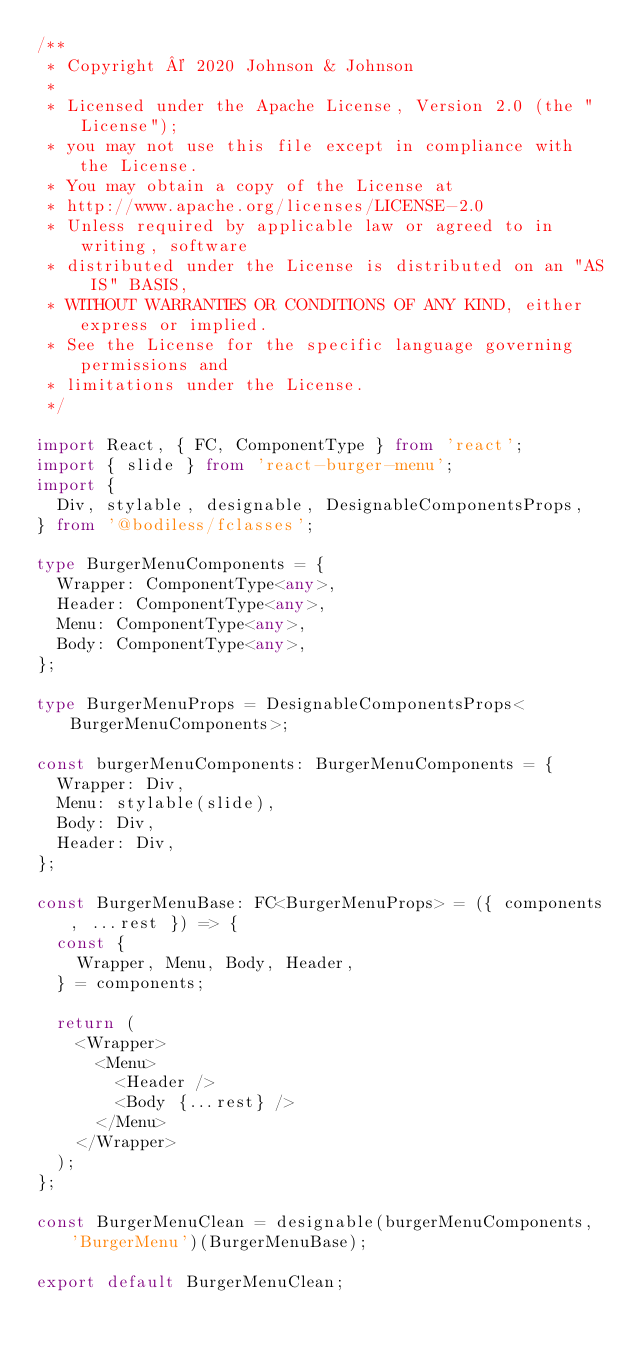Convert code to text. <code><loc_0><loc_0><loc_500><loc_500><_TypeScript_>/**
 * Copyright © 2020 Johnson & Johnson
 *
 * Licensed under the Apache License, Version 2.0 (the "License");
 * you may not use this file except in compliance with the License.
 * You may obtain a copy of the License at
 * http://www.apache.org/licenses/LICENSE-2.0
 * Unless required by applicable law or agreed to in writing, software
 * distributed under the License is distributed on an "AS IS" BASIS,
 * WITHOUT WARRANTIES OR CONDITIONS OF ANY KIND, either express or implied.
 * See the License for the specific language governing permissions and
 * limitations under the License.
 */

import React, { FC, ComponentType } from 'react';
import { slide } from 'react-burger-menu';
import {
  Div, stylable, designable, DesignableComponentsProps,
} from '@bodiless/fclasses';

type BurgerMenuComponents = {
  Wrapper: ComponentType<any>,
  Header: ComponentType<any>,
  Menu: ComponentType<any>,
  Body: ComponentType<any>,
};

type BurgerMenuProps = DesignableComponentsProps<BurgerMenuComponents>;

const burgerMenuComponents: BurgerMenuComponents = {
  Wrapper: Div,
  Menu: stylable(slide),
  Body: Div,
  Header: Div,
};

const BurgerMenuBase: FC<BurgerMenuProps> = ({ components, ...rest }) => {
  const {
    Wrapper, Menu, Body, Header,
  } = components;

  return (
    <Wrapper>
      <Menu>
        <Header />
        <Body {...rest} />
      </Menu>
    </Wrapper>
  );
};

const BurgerMenuClean = designable(burgerMenuComponents, 'BurgerMenu')(BurgerMenuBase);

export default BurgerMenuClean;
</code> 